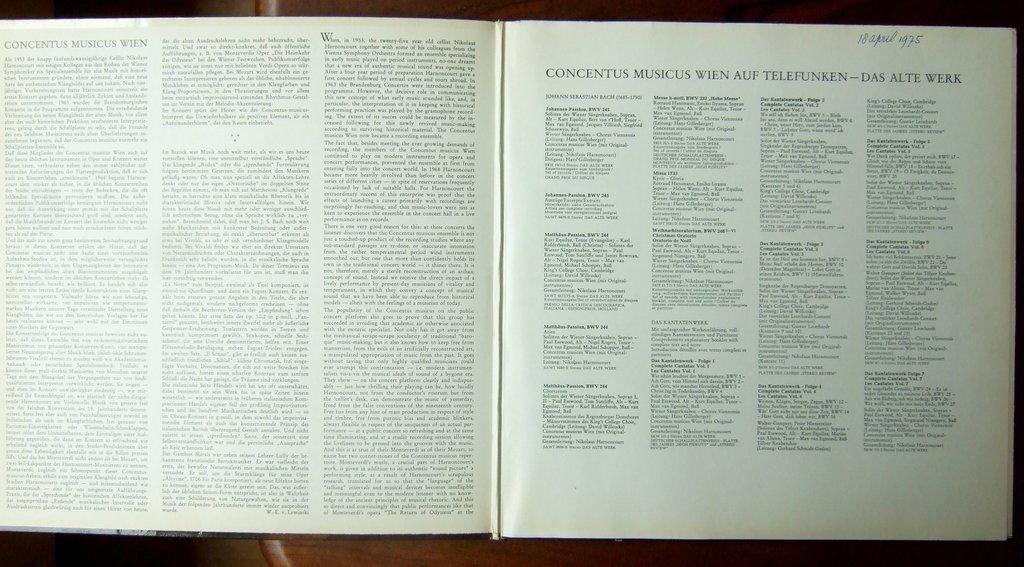<image>
Provide a brief description of the given image. Concentus Musicus Wien is the title of the page a book is open to. 